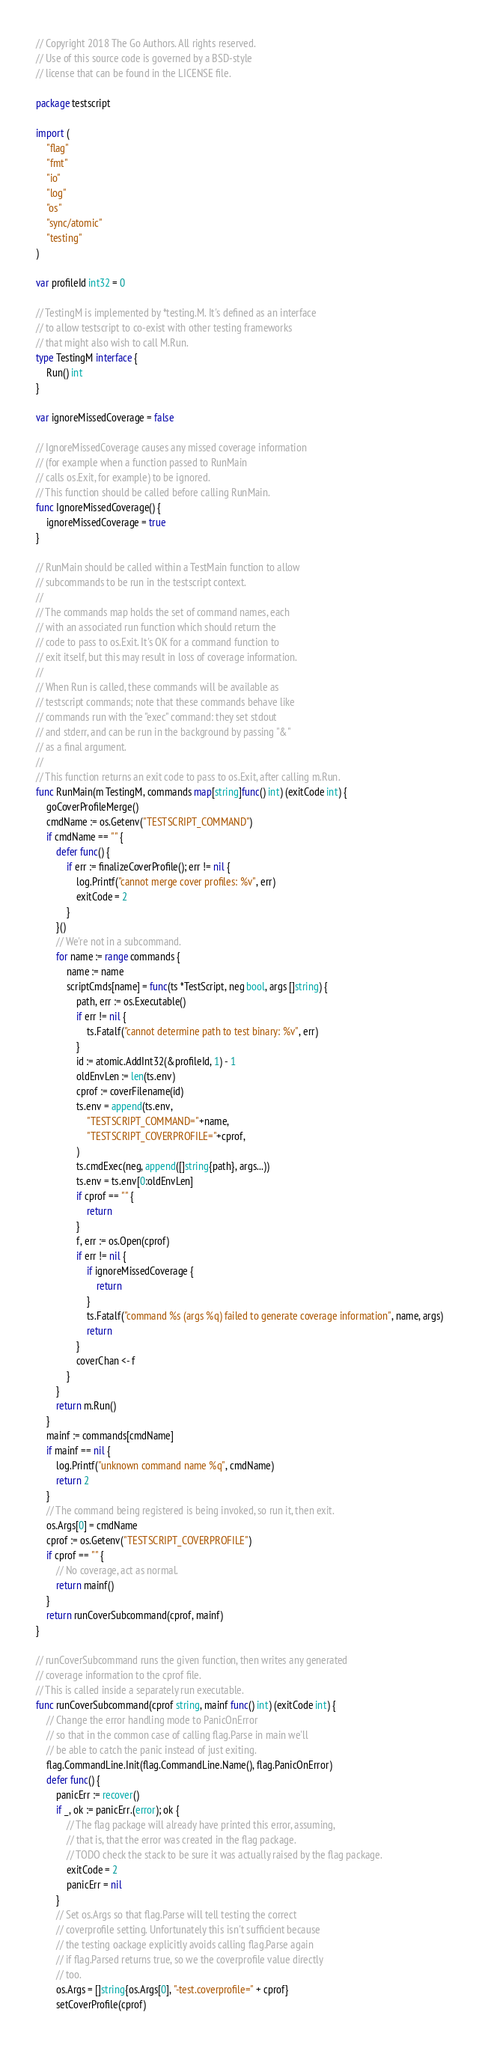<code> <loc_0><loc_0><loc_500><loc_500><_Go_>// Copyright 2018 The Go Authors. All rights reserved.
// Use of this source code is governed by a BSD-style
// license that can be found in the LICENSE file.

package testscript

import (
	"flag"
	"fmt"
	"io"
	"log"
	"os"
	"sync/atomic"
	"testing"
)

var profileId int32 = 0

// TestingM is implemented by *testing.M. It's defined as an interface
// to allow testscript to co-exist with other testing frameworks
// that might also wish to call M.Run.
type TestingM interface {
	Run() int
}

var ignoreMissedCoverage = false

// IgnoreMissedCoverage causes any missed coverage information
// (for example when a function passed to RunMain
// calls os.Exit, for example) to be ignored.
// This function should be called before calling RunMain.
func IgnoreMissedCoverage() {
	ignoreMissedCoverage = true
}

// RunMain should be called within a TestMain function to allow
// subcommands to be run in the testscript context.
//
// The commands map holds the set of command names, each
// with an associated run function which should return the
// code to pass to os.Exit. It's OK for a command function to
// exit itself, but this may result in loss of coverage information.
//
// When Run is called, these commands will be available as
// testscript commands; note that these commands behave like
// commands run with the "exec" command: they set stdout
// and stderr, and can be run in the background by passing "&"
// as a final argument.
//
// This function returns an exit code to pass to os.Exit, after calling m.Run.
func RunMain(m TestingM, commands map[string]func() int) (exitCode int) {
	goCoverProfileMerge()
	cmdName := os.Getenv("TESTSCRIPT_COMMAND")
	if cmdName == "" {
		defer func() {
			if err := finalizeCoverProfile(); err != nil {
				log.Printf("cannot merge cover profiles: %v", err)
				exitCode = 2
			}
		}()
		// We're not in a subcommand.
		for name := range commands {
			name := name
			scriptCmds[name] = func(ts *TestScript, neg bool, args []string) {
				path, err := os.Executable()
				if err != nil {
					ts.Fatalf("cannot determine path to test binary: %v", err)
				}
				id := atomic.AddInt32(&profileId, 1) - 1
				oldEnvLen := len(ts.env)
				cprof := coverFilename(id)
				ts.env = append(ts.env,
					"TESTSCRIPT_COMMAND="+name,
					"TESTSCRIPT_COVERPROFILE="+cprof,
				)
				ts.cmdExec(neg, append([]string{path}, args...))
				ts.env = ts.env[0:oldEnvLen]
				if cprof == "" {
					return
				}
				f, err := os.Open(cprof)
				if err != nil {
					if ignoreMissedCoverage {
						return
					}
					ts.Fatalf("command %s (args %q) failed to generate coverage information", name, args)
					return
				}
				coverChan <- f
			}
		}
		return m.Run()
	}
	mainf := commands[cmdName]
	if mainf == nil {
		log.Printf("unknown command name %q", cmdName)
		return 2
	}
	// The command being registered is being invoked, so run it, then exit.
	os.Args[0] = cmdName
	cprof := os.Getenv("TESTSCRIPT_COVERPROFILE")
	if cprof == "" {
		// No coverage, act as normal.
		return mainf()
	}
	return runCoverSubcommand(cprof, mainf)
}

// runCoverSubcommand runs the given function, then writes any generated
// coverage information to the cprof file.
// This is called inside a separately run executable.
func runCoverSubcommand(cprof string, mainf func() int) (exitCode int) {
	// Change the error handling mode to PanicOnError
	// so that in the common case of calling flag.Parse in main we'll
	// be able to catch the panic instead of just exiting.
	flag.CommandLine.Init(flag.CommandLine.Name(), flag.PanicOnError)
	defer func() {
		panicErr := recover()
		if _, ok := panicErr.(error); ok {
			// The flag package will already have printed this error, assuming,
			// that is, that the error was created in the flag package.
			// TODO check the stack to be sure it was actually raised by the flag package.
			exitCode = 2
			panicErr = nil
		}
		// Set os.Args so that flag.Parse will tell testing the correct
		// coverprofile setting. Unfortunately this isn't sufficient because
		// the testing oackage explicitly avoids calling flag.Parse again
		// if flag.Parsed returns true, so we the coverprofile value directly
		// too.
		os.Args = []string{os.Args[0], "-test.coverprofile=" + cprof}
		setCoverProfile(cprof)
</code> 